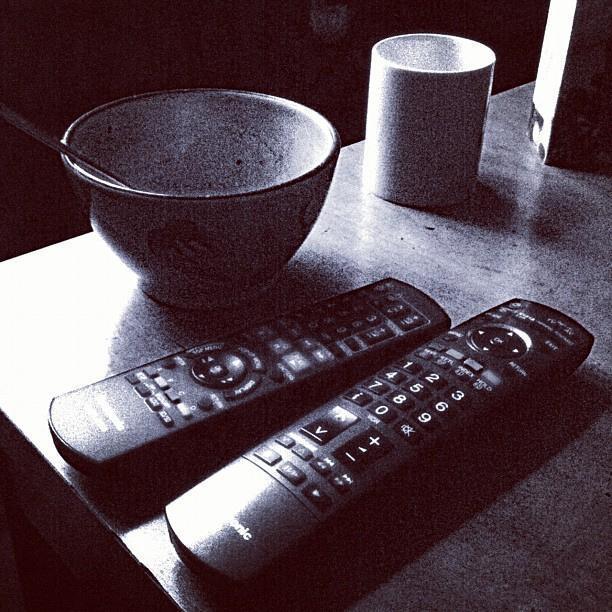How many electronic devices are on the table?
Give a very brief answer. 2. How many remotes can be seen?
Give a very brief answer. 2. 